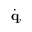Convert formula to latex. <formula><loc_0><loc_0><loc_500><loc_500>{ \dot { q } } ,</formula> 